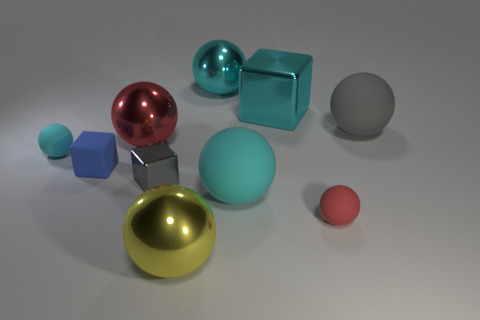Do the gray object that is behind the small gray object and the tiny gray object right of the big red ball have the same material?
Your answer should be compact. No. What size is the matte ball that is behind the big cyan matte object and in front of the gray ball?
Provide a short and direct response. Small. There is a gray thing that is the same size as the cyan cube; what material is it?
Offer a very short reply. Rubber. There is a ball that is on the left side of the big metal thing that is left of the large yellow sphere; what number of small red things are right of it?
Keep it short and to the point. 1. Do the tiny sphere that is left of the small metal cube and the large metallic object behind the large cyan metal block have the same color?
Make the answer very short. Yes. There is a big metallic sphere that is both on the right side of the big red thing and behind the tiny cyan sphere; what color is it?
Your answer should be compact. Cyan. What number of red objects have the same size as the gray metallic thing?
Provide a succinct answer. 1. What shape is the big cyan shiny object that is behind the block behind the blue block?
Offer a terse response. Sphere. What is the shape of the large metal thing that is to the left of the big shiny ball that is in front of the tiny matte thing that is right of the blue rubber thing?
Provide a succinct answer. Sphere. What number of gray shiny objects are the same shape as the small blue rubber object?
Provide a short and direct response. 1. 